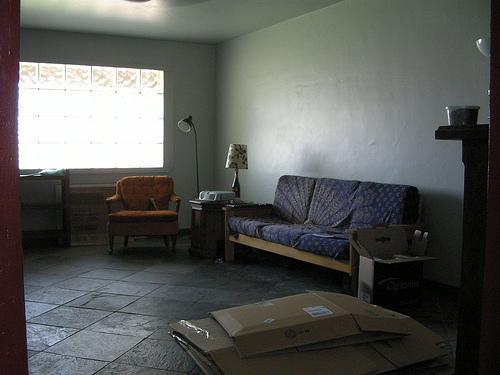How many lamps in the room?
Give a very brief answer. 2. 